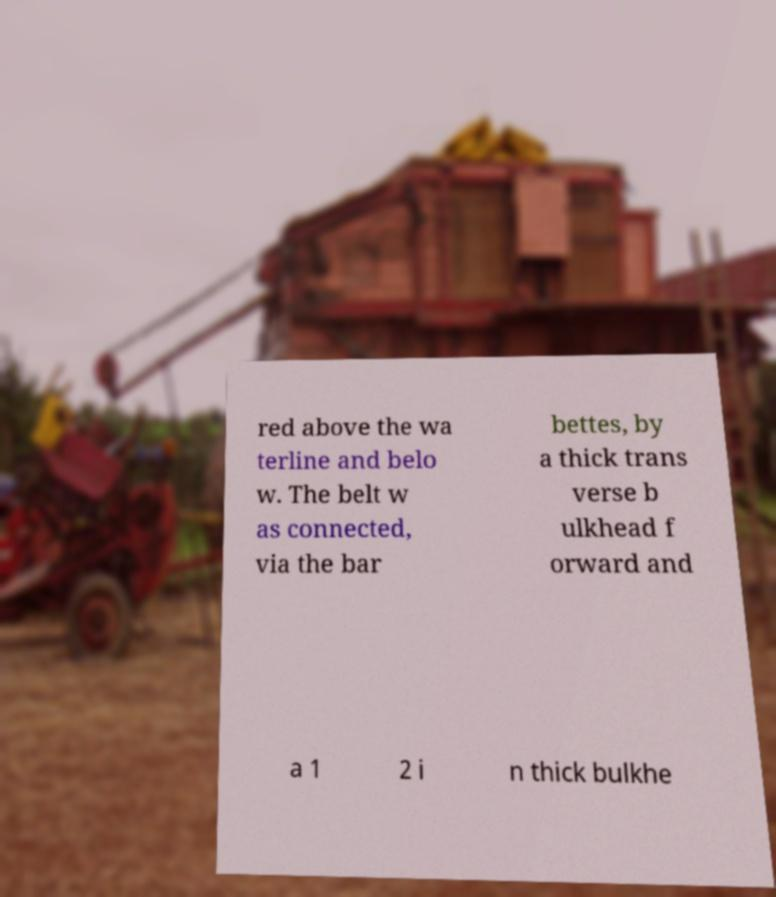Could you extract and type out the text from this image? red above the wa terline and belo w. The belt w as connected, via the bar bettes, by a thick trans verse b ulkhead f orward and a 1 2 i n thick bulkhe 